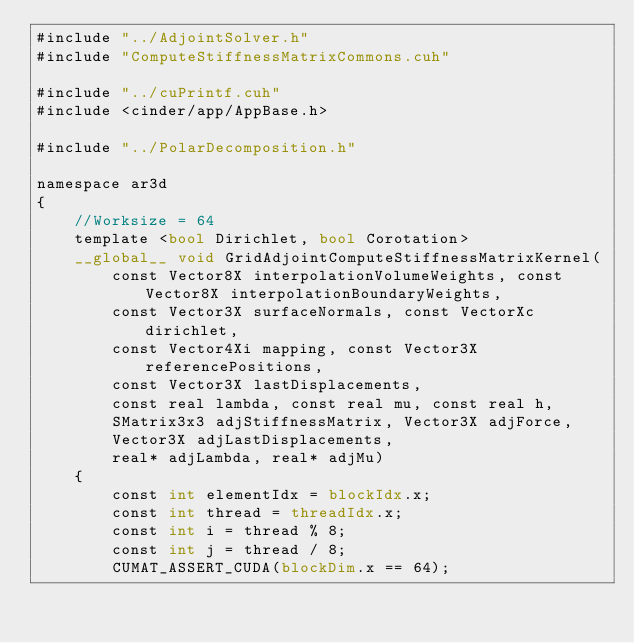<code> <loc_0><loc_0><loc_500><loc_500><_Cuda_>#include "../AdjointSolver.h"
#include "ComputeStiffnessMatrixCommons.cuh"

#include "../cuPrintf.cuh"
#include <cinder/app/AppBase.h>

#include "../PolarDecomposition.h"

namespace ar3d
{
    //Worksize = 64
    template <bool Dirichlet, bool Corotation>
    __global__ void GridAdjointComputeStiffnessMatrixKernel(
        const Vector8X interpolationVolumeWeights, const Vector8X interpolationBoundaryWeights,
        const Vector3X surfaceNormals, const VectorXc dirichlet, 
        const Vector4Xi mapping, const Vector3X referencePositions,
        const Vector3X lastDisplacements,
        const real lambda, const real mu, const real h,
        SMatrix3x3 adjStiffnessMatrix, Vector3X adjForce,
        Vector3X adjLastDisplacements,
        real* adjLambda, real* adjMu)
    {
        const int elementIdx = blockIdx.x;
        const int thread = threadIdx.x;
        const int i = thread % 8;
        const int j = thread / 8;
        CUMAT_ASSERT_CUDA(blockDim.x == 64);</code> 